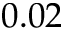<formula> <loc_0><loc_0><loc_500><loc_500>0 . 0 2</formula> 